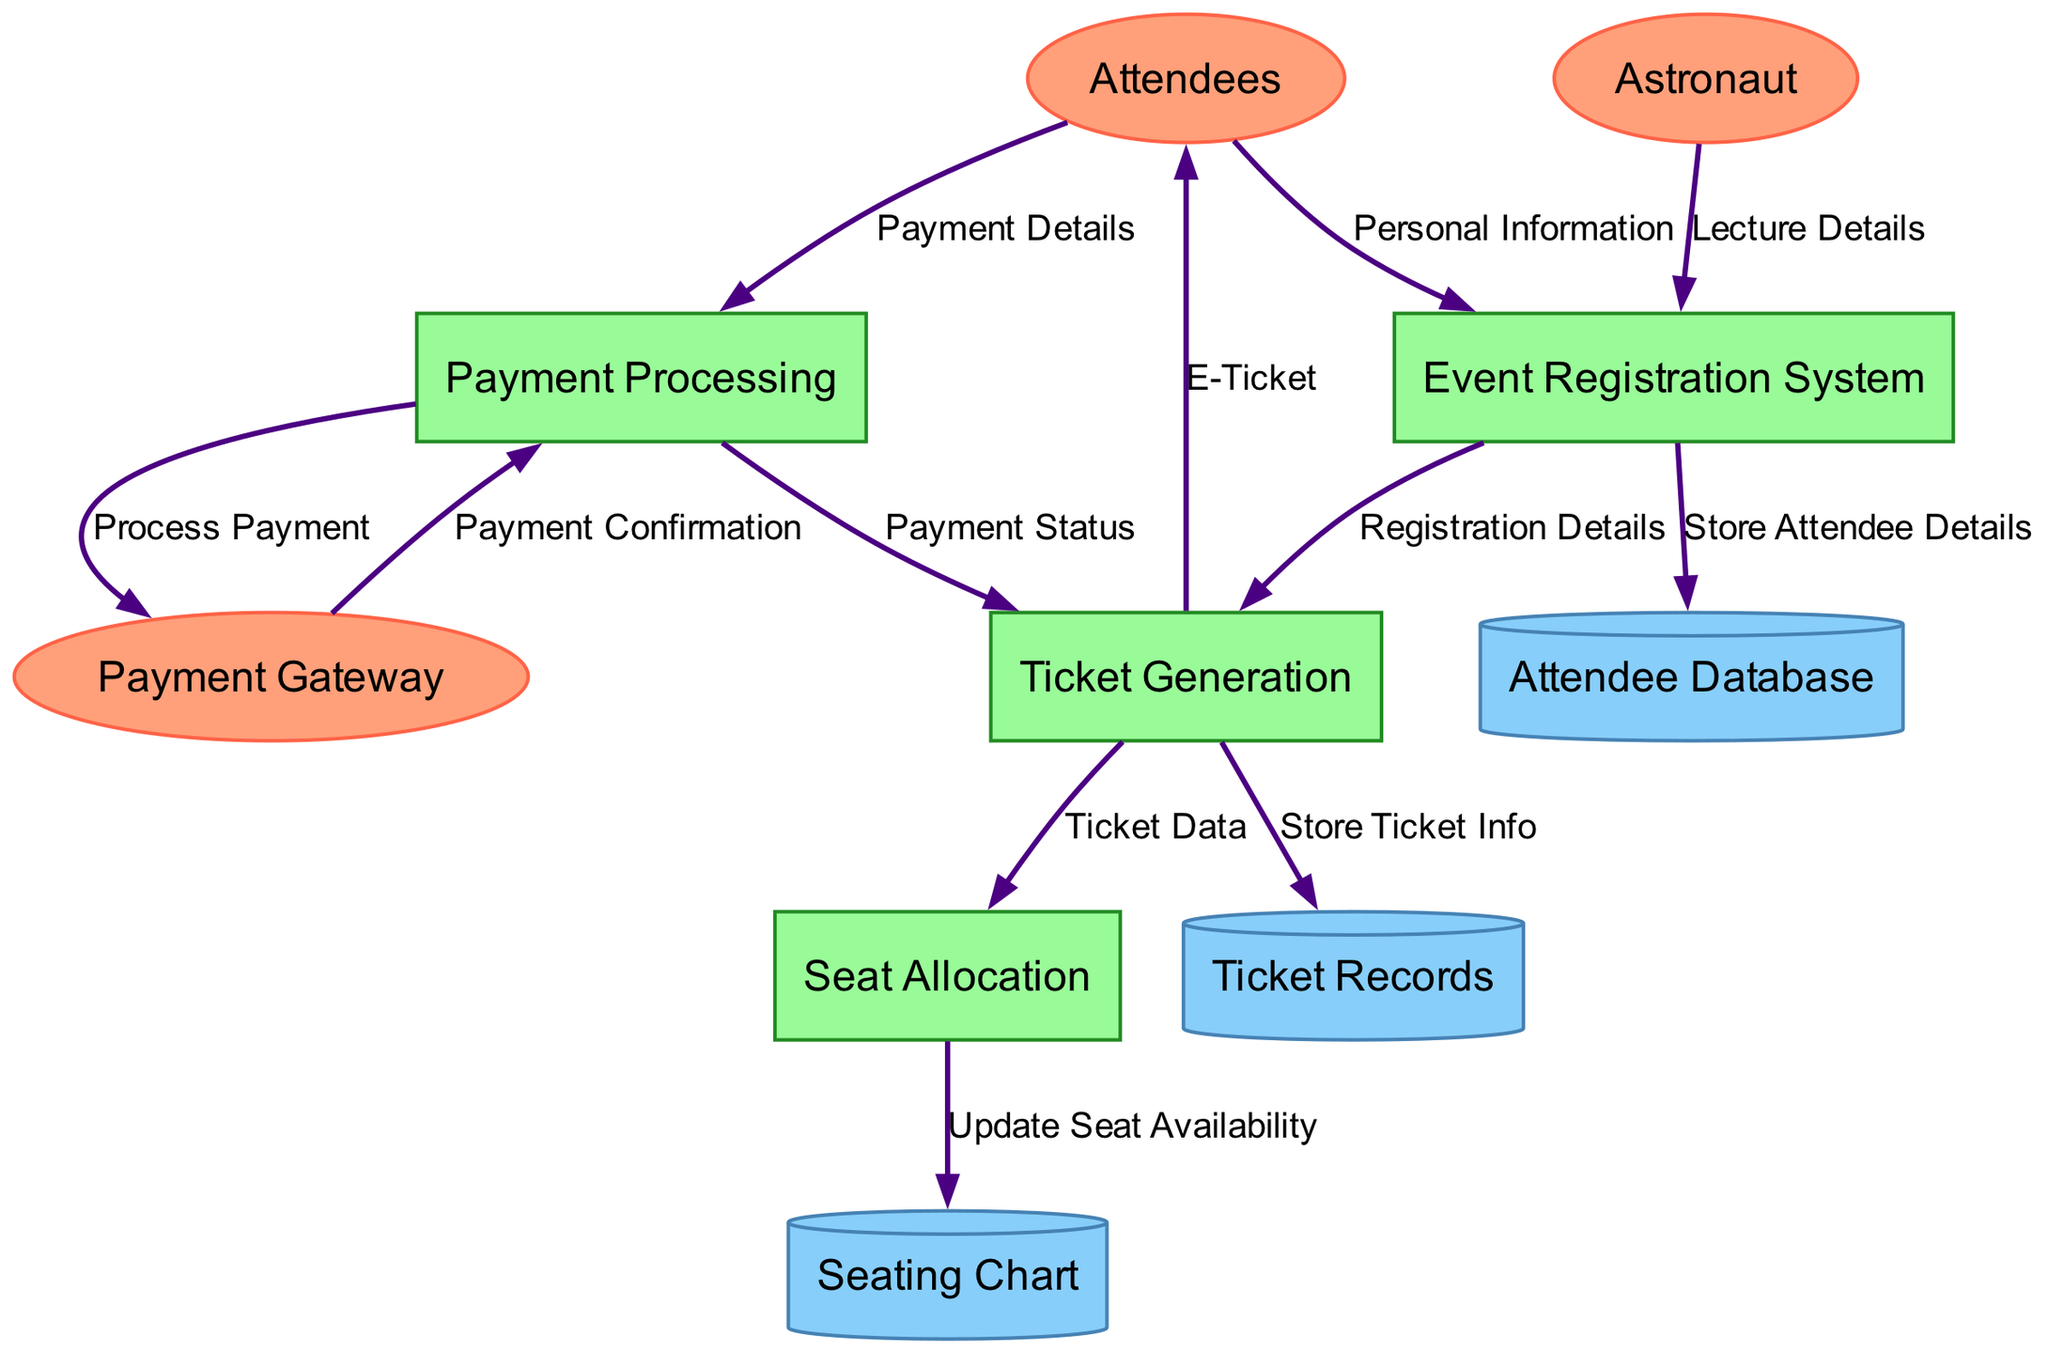What entities are involved in the event registration process? The diagram lists three external entities involved: Attendees, Astronaut, and Payment Gateway.
Answer: Attendees, Astronaut, Payment Gateway How many processes are shown in the diagram? The diagram displays four processes related to event registration and ticket sales: Event Registration System, Ticket Generation, Seat Allocation, and Payment Processing.
Answer: Four What is the data flow from Attendees to the Event Registration System? The data flow from Attendees to the Event Registration System is labeled "Personal Information," indicating that Attendees provide their personal details during registration.
Answer: Personal Information Which process updates seat availability? The process responsible for updating seat availability is the Seat Allocation process. This process sends updated information to the Seating Chart data store.
Answer: Seat Allocation What does the Ticket Generation process send to the Attendees? The Ticket Generation process sends an E-Ticket to Attendees after the payment status is confirmed, concluding their ticket purchase process.
Answer: E-Ticket What is the relationship between Ticket Generation and Payment Processing? Ticket Generation requires a Payment Status from the Payment Processing system to finalize the ticket issuance, establishing a dependency between these two processes.
Answer: Payment Status How does the Payment Gateway interact with Payment Processing? The Payment Gateway processes the payment initiated by the Payment Processing system and returns the Payment Confirmation, signifying a two-way interaction.
Answer: Payment Confirmation What data is stored in the Ticket Records? The Ticket Generation process sends a flow labeled "Store Ticket Info" to the Ticket Records, indicating that detailed ticket information is saved there.
Answer: Store Ticket Info 